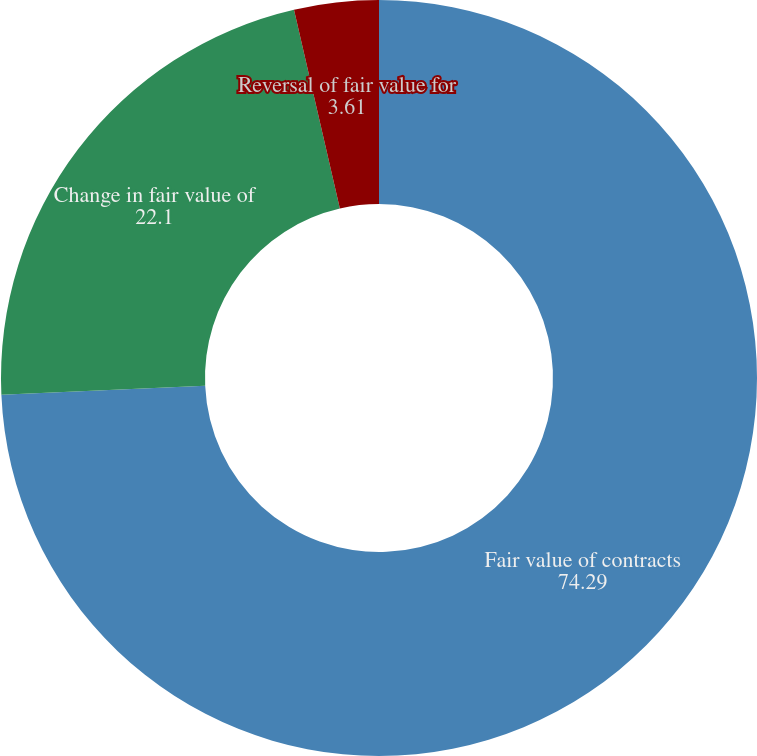<chart> <loc_0><loc_0><loc_500><loc_500><pie_chart><fcel>Fair value of contracts<fcel>Change in fair value of<fcel>Reversal of fair value for<nl><fcel>74.29%<fcel>22.1%<fcel>3.61%<nl></chart> 